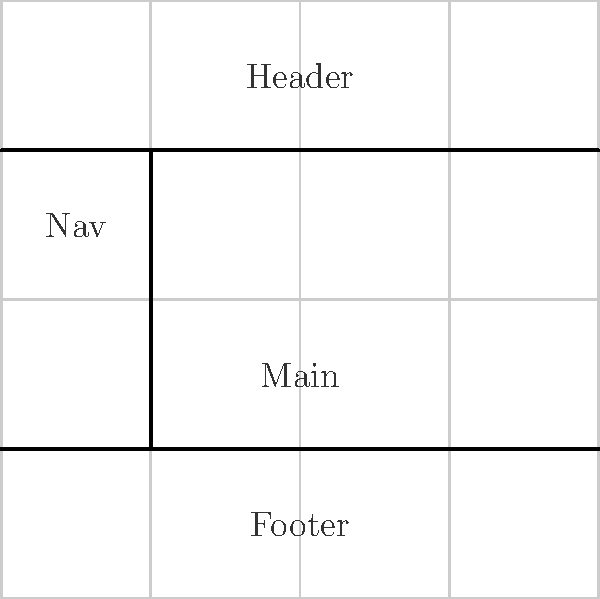In designing a responsive layout for showcasing traditional village crafts using CSS Grid, which CSS Grid property would you use to create the layout shown in the diagram, ensuring that the nav section remains at a fixed width of 200px while the main content area expands to fill the remaining space? To create the layout shown in the diagram using CSS Grid, we need to follow these steps:

1. Set up the basic grid structure:
   - Use `display: grid;` on the container element.
   - Define grid areas using `grid-template-areas` for the layout structure.

2. Create the fixed-width nav and expanding main content:
   - Use `grid-template-columns` to define the column structure.
   - The first column should be fixed at 200px for the nav.
   - The second column should expand to fill the remaining space.

3. The CSS Grid property that allows us to create a fixed-width column and an expanding column is `grid-template-columns`.

4. The correct value for `grid-template-columns` would be:
   `grid-template-columns: 200px 1fr;`

   Here, `200px` sets the fixed width for the nav column, and `1fr` (fractional unit) allows the main content to expand and fill the remaining space.

5. This setup ensures that regardless of the screen size, the nav maintains its 200px width while the main content area flexibly adjusts to fill the available space, creating a responsive layout suitable for showcasing traditional village crafts.
Answer: grid-template-columns: 200px 1fr; 